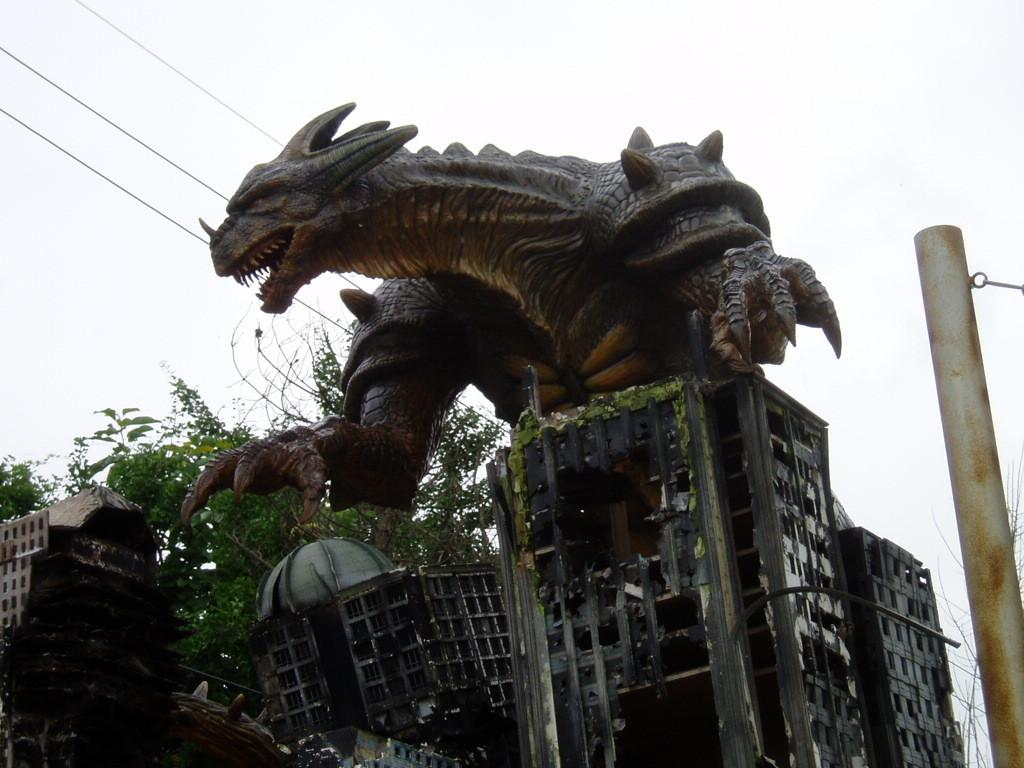What can be seen in the foreground of the image? In the foreground of the image, there are buildings, a pole, trees, and a statue of an animal. What is present in the background of the image? In the background of the image, there are wires and the sky visible. Can you describe the statue in the foreground? The statue in the foreground is of an animal. What might be the time of day when the image was taken? The image might have been taken during the day, as the sky is visible. Reasoning: Let'g: Let's think step by step in order to produce the conversation. We start by identifying the main subjects and objects in the image based on the provided facts. We then formulate questions that focus on the location and characteristics of these subjects and objects, ensuring that each question can be answered definitively with the information given. We avoid yes/no questions and ensure that the language is simple and clear. Absurd Question/Answer: What advice does the statue of the animal give in the image? There is no indication in the image that the statue of the animal is giving any advice. What type of throat condition can be seen in the image? There is no throat condition present in the image. What type of pail is being used to water the plants in the image? There is no pail or plants visible in the image. 